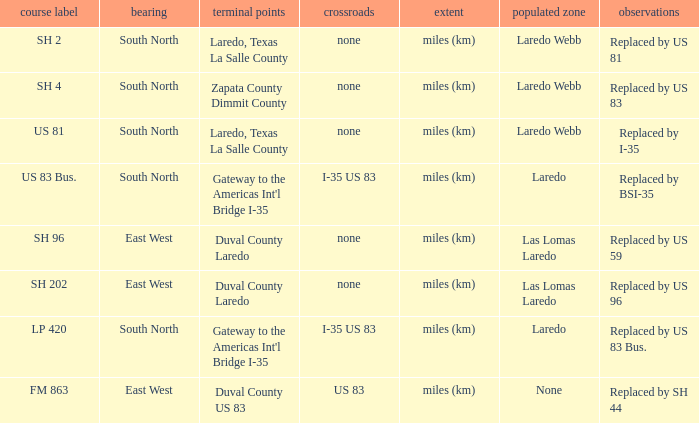How many termini are there that have "east west" listed in their direction section, "none" listed in their junction section, and have a route name of "sh 202"? 1.0. 